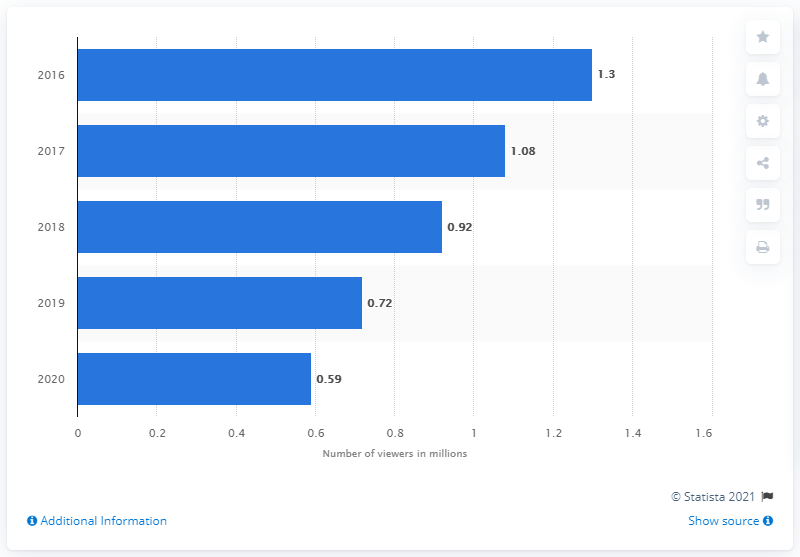Indicate a few pertinent items in this graphic. In 2020, the average number of people who watched AMC in the United States was approximately 0.59 million. In 2019, the number of people who watched AMC was 0.72. 